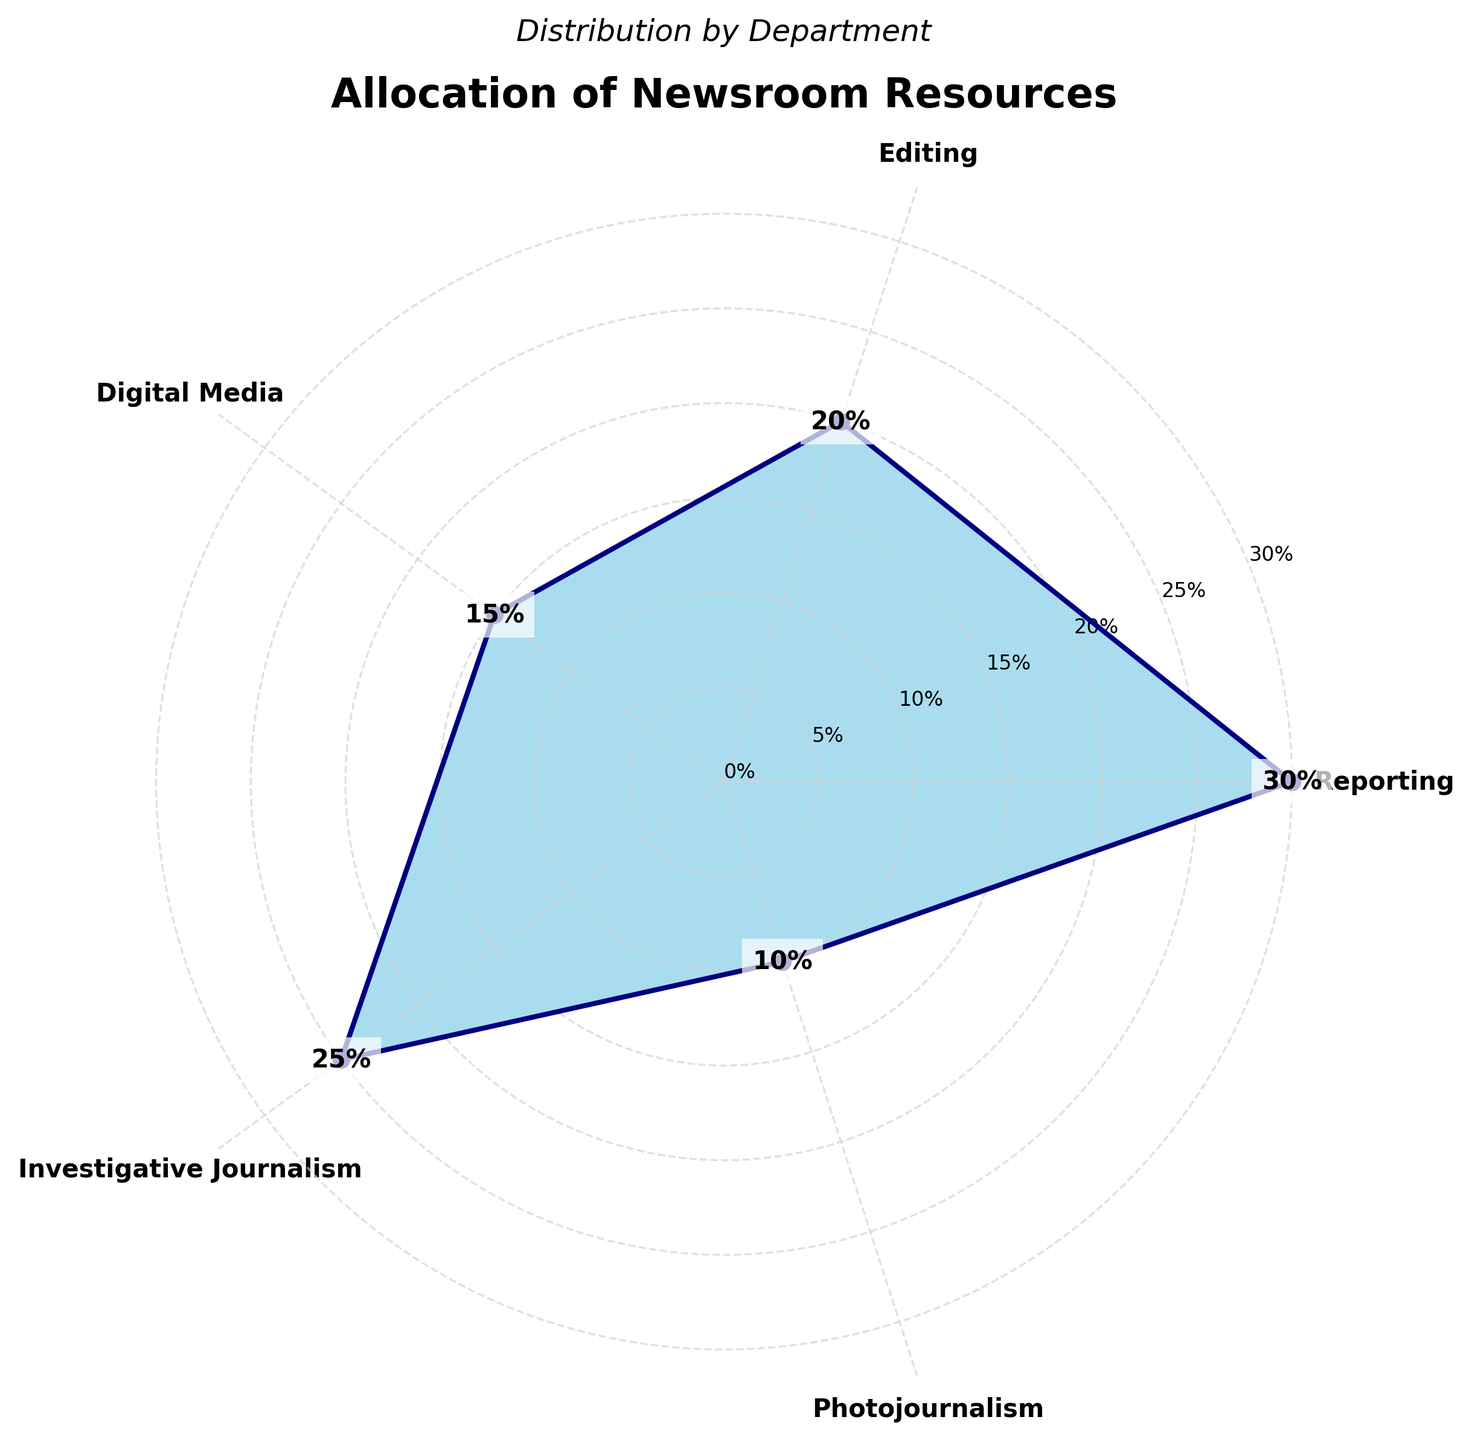What's the title of the figure? The title is often placed at the top of the figure and is usually larger in font size than other text components. In this case, the title is "Allocation of Newsroom Resources".
Answer: Allocation of Newsroom Resources Which department has the highest allocation of resources? By observing the figure, we can identify the department with the highest percentage on the polar chart. The largest area marked is for Reporting, which stands at 30%.
Answer: Reporting How much more resources does Reporting receive compared to Photojournalism? To find the difference, we subtract the percentage allocated to Photojournalism from the percentage allocated to Reporting. That is, 30% (Reporting) - 10% (Photojournalism) = 20%.
Answer: 20% What is the average percentage allocation of resources across all departments? To calculate the average, we sum all the percentages and divide by the number of departments: (30 + 20 + 15 + 25 + 10) / 5 = 100 / 5 = 20.
Answer: 20% Which departments receive less than 20% of the resources? By examining the figure, departments with percentages below 20% are identified. Digital Media (15%) and Photojournalism (10%) are the departments that meet this criterion.
Answer: Digital Media, Photojournalism What's the combined percentage allocation for Digital Media and Investigative Journalism? Adding the percentages for Digital Media and Investigative Journalism gives us: 15% + 25% = 40%.
Answer: 40% Compare the resource allocation for Editing and Investigative Journalism. Which one is higher and by how much? Investigative Journalism has 25% while Editing has 20%. The difference is 25% - 20% = 5%, with Investigative Journalism having a higher allocation.
Answer: Investigative Journalism by 5% What is the resource allocation in Digital Media as a fraction of the total allocation across all departments? First, determine the percentage for Digital Media (15%). As a fraction of 100%, it is 15/100, which simplifies to 3/20.
Answer: 3/20 If the resource allocation for Photojournalism doubled, what would be the new percentage and how would it compare to Investigative Journalism? Doubling Photojournalism's allocation would be 10% * 2 = 20%. Comparing it to Investigative Journalism's 25%, it is still less by 5%.
Answer: New percentage: 20%, Less by 5% Identify the department with the smallest percentage allocation and its value. The department with the smallest segment in the polar chart is Photojournalism, which has a 10% allocation.
Answer: Photojournalism, 10% 